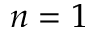<formula> <loc_0><loc_0><loc_500><loc_500>n = 1</formula> 